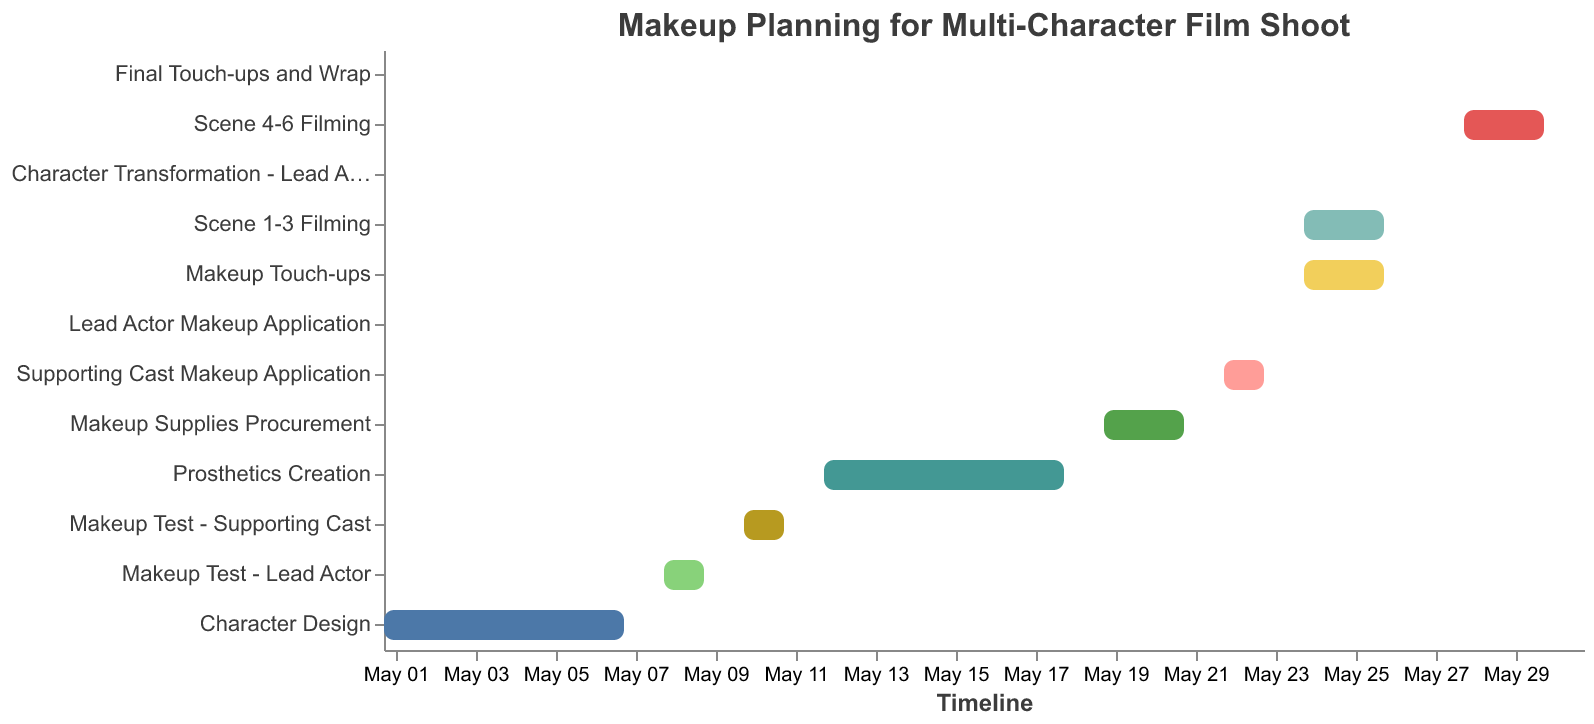How long does the Character Design phase last? The Character Design phase starts on May 1 and ends on May 7. By looking at the duration in the figure, it is indicated as 7 days.
Answer: 7 days When does the Makeup Supplies Procurement start and end? The Makeup Supplies Procurement starts on May 19 and ends on May 21 as indicated by the timeline section for this task in the Gantt chart.
Answer: May 19 - May 21 What task is scheduled to be completed in a single day on May 27? By looking at the task bars on the Gantt chart, Character Transformation - Lead Actor is scheduled to be completed in a single day on May 27.
Answer: Character Transformation - Lead Actor Which tasks overlap on May 24? The tasks overlapping on May 24 are 'Scene 1-3 Filming' and 'Makeup Touch-ups', as indicated by their bars starting on this date.
Answer: Scene 1-3 Filming and Makeup Touch-ups What is the total duration for all makeup application tasks? The total duration includes 'Lead Actor Makeup Application' (1 day) and 'Supporting Cast Makeup Application' (2 days). Adding these gives a total of 3 days.
Answer: 3 days When do the filming tasks ('Scene 1-3 Filming' and 'Scene 4-6 Filming') start and end? 'Scene 1-3 Filming' starts on May 24 and ends on May 26. 'Scene 4-6 Filming' starts on May 28 and ends on May 30.
Answer: May 24 - May 26 and May 28 - May 30 How many days between the end of Prosthetics Creation and the start of the Lead Actor Makeup Application? Prosthetics Creation ends on May 18 and Lead Actor Makeup Application starts on May 22. The days between are May 19, May 20, and May 21, totaling 3 days.
Answer: 3 days What's the duration of the Final Touch-ups and Wrap task? The Final Touch-ups and Wrap task starts and ends on May 31, making its duration 1 day.
Answer: 1 day 